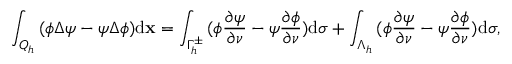<formula> <loc_0><loc_0><loc_500><loc_500>\int _ { { Q _ { h } } } { ( \phi \Delta \psi - \psi } \Delta \phi ) d \mathbf x = \int _ { \Gamma _ { h } ^ { \pm } } { ( \phi { \frac { \partial \psi } { \partial \nu } } } - \psi { \frac { \partial \phi } { \partial \nu } } ) d \sigma + \int _ { \Lambda _ { h } } { ( \phi { \frac { \partial \psi } { \partial \nu } } } - \psi { \frac { \partial \phi } { \partial \nu } } ) d \sigma ,</formula> 